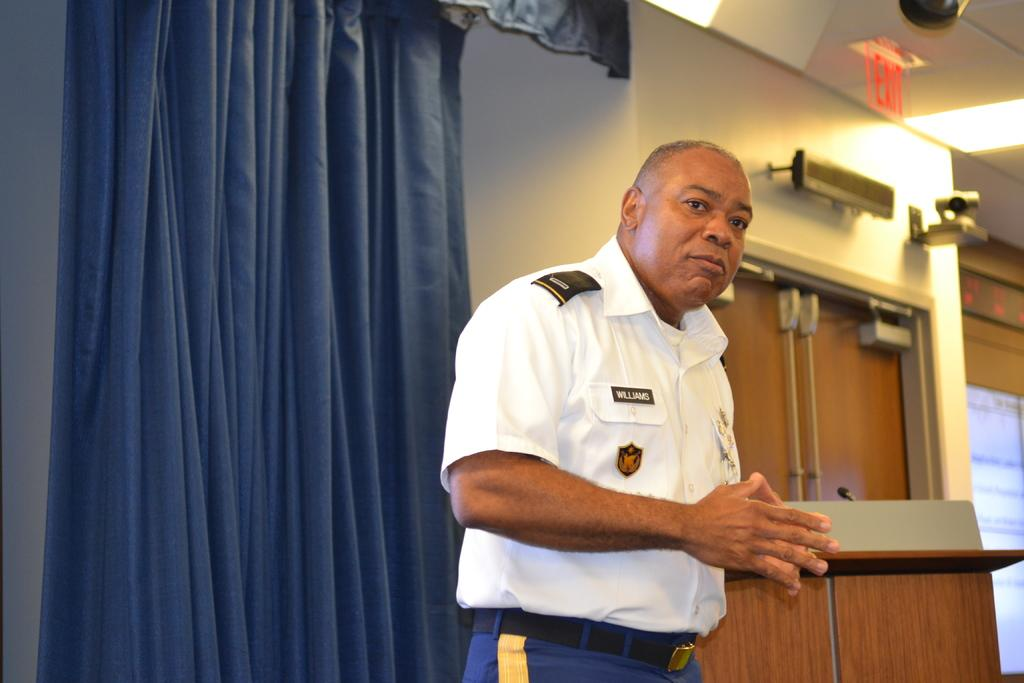What is the main subject of the image? There is a person standing in the center of the image. What can be seen in the background of the image? There is a wall, a curtain, a door, a wooden stand, and a few other objects in the background of the image. Can you describe the wall in the background? The wall is in the background of the image, but no specific details about its appearance are provided. What type of secretary is sitting on the wooden stand in the image? There is no secretary present in the image; the wooden stand is one of the objects in the background. How many matches are visible in the image? There is no mention of matches in the image, so it is not possible to determine their presence or quantity. 